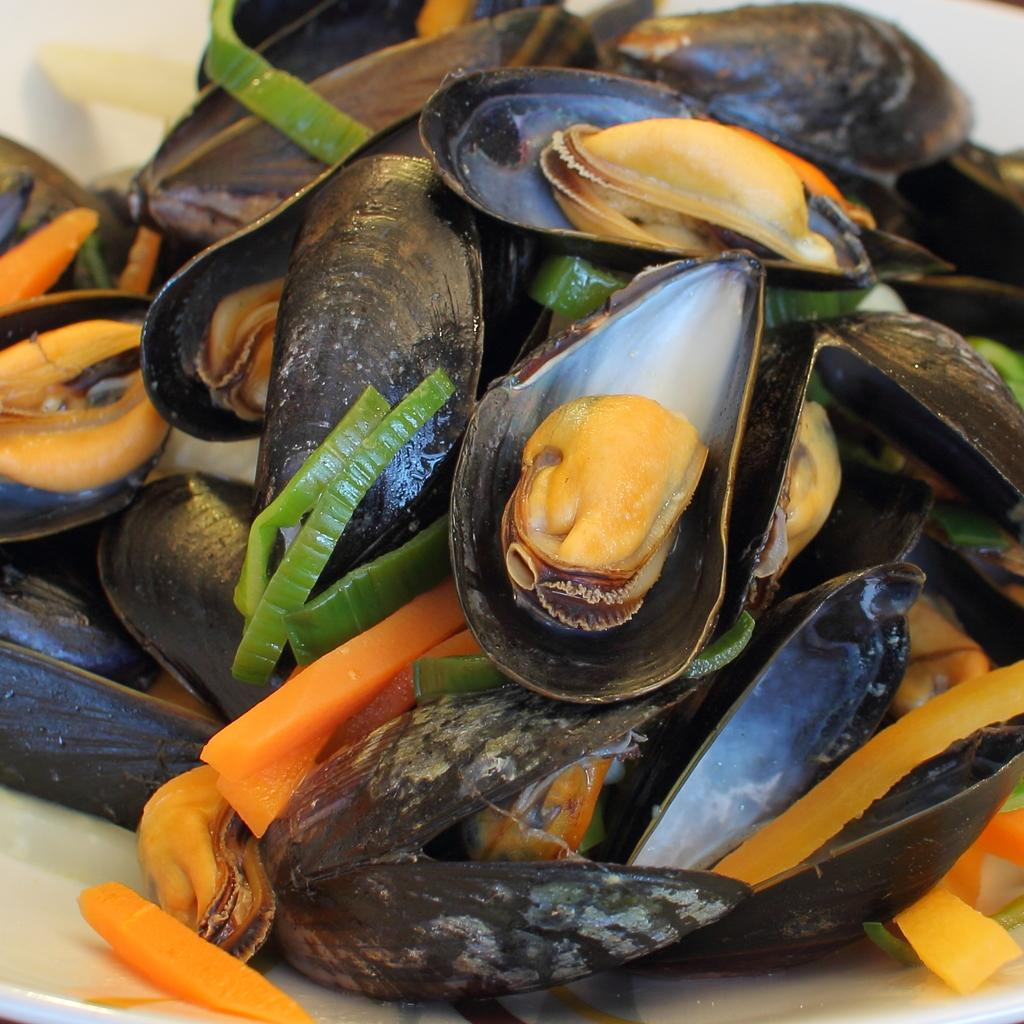What objects are located in the middle of the image? There are shells and vegetable pieces in the middle of the image. How are the shells and vegetable pieces arranged? The shells and vegetable pieces are arranged on a surface. What is the color of the background in the image? The background of the image is white in color. What type of metal is used to create the vacation spot in the image? There is no vacation spot or metal present in the image; it features shells and vegetable pieces arranged on a surface with a white background. 